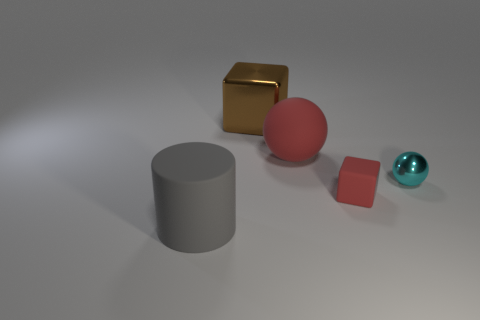What color is the other object that is the same shape as the brown thing?
Offer a very short reply. Red. Are there fewer small red things that are to the left of the matte cylinder than rubber cylinders that are behind the small metal sphere?
Offer a very short reply. No. How many other things are there of the same shape as the big red object?
Offer a very short reply. 1. Are there fewer red cubes in front of the large cylinder than big red rubber spheres?
Provide a succinct answer. Yes. There is a small thing behind the red cube; what is its material?
Your response must be concise. Metal. What number of other things are there of the same size as the gray rubber cylinder?
Ensure brevity in your answer.  2. Are there fewer cyan balls than large matte objects?
Your response must be concise. Yes. The small matte thing is what shape?
Provide a short and direct response. Cube. Do the large rubber thing behind the gray thing and the small ball have the same color?
Your answer should be compact. No. What is the shape of the object that is to the left of the big rubber sphere and in front of the cyan object?
Offer a very short reply. Cylinder. 